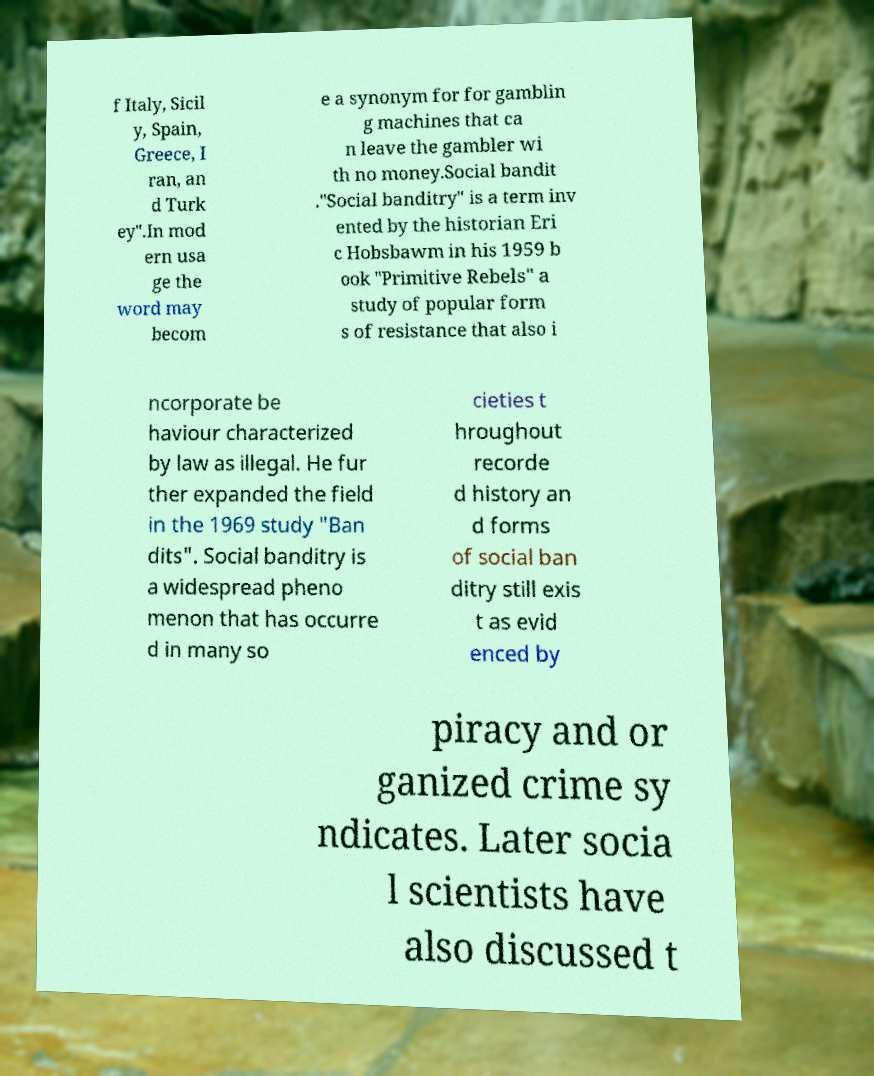What messages or text are displayed in this image? I need them in a readable, typed format. f Italy, Sicil y, Spain, Greece, I ran, an d Turk ey".In mod ern usa ge the word may becom e a synonym for for gamblin g machines that ca n leave the gambler wi th no money.Social bandit ."Social banditry" is a term inv ented by the historian Eri c Hobsbawm in his 1959 b ook "Primitive Rebels" a study of popular form s of resistance that also i ncorporate be haviour characterized by law as illegal. He fur ther expanded the field in the 1969 study "Ban dits". Social banditry is a widespread pheno menon that has occurre d in many so cieties t hroughout recorde d history an d forms of social ban ditry still exis t as evid enced by piracy and or ganized crime sy ndicates. Later socia l scientists have also discussed t 